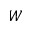Convert formula to latex. <formula><loc_0><loc_0><loc_500><loc_500>W</formula> 